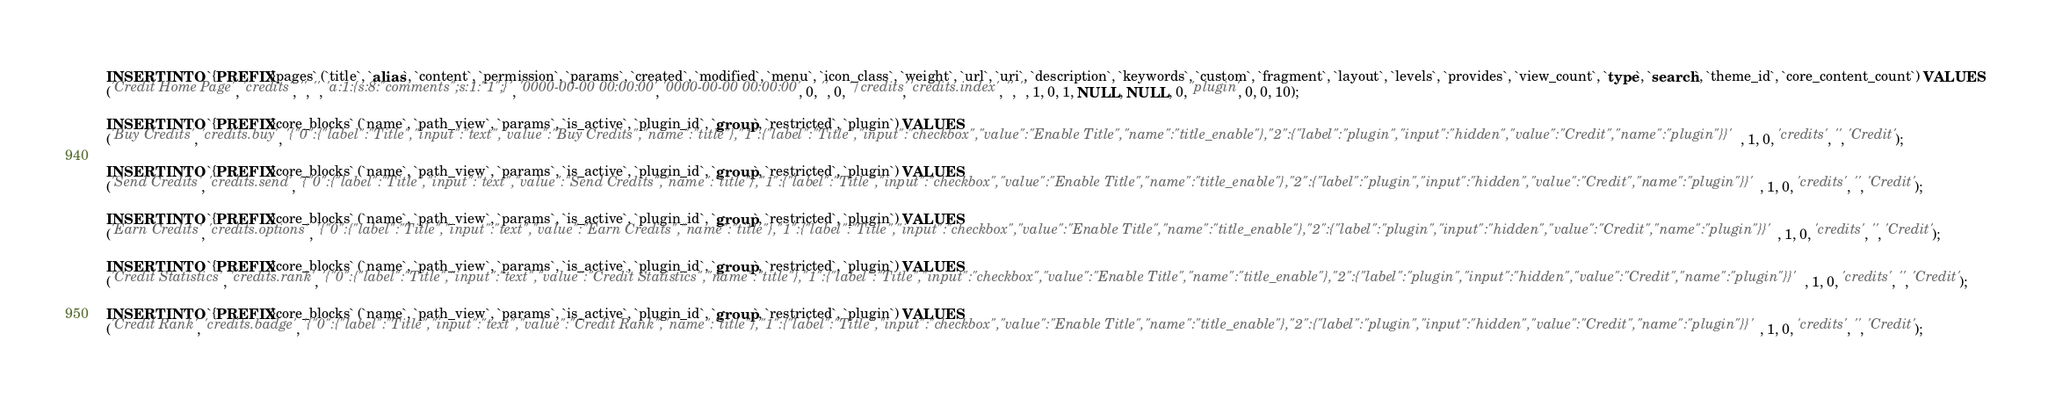Convert code to text. <code><loc_0><loc_0><loc_500><loc_500><_SQL_>
INSERT INTO `{PREFIX}pages` (`title`, `alias`, `content`, `permission`, `params`, `created`, `modified`, `menu`, `icon_class`, `weight`, `url`, `uri`, `description`, `keywords`, `custom`, `fragment`, `layout`, `levels`, `provides`, `view_count`, `type`, `search`, `theme_id`, `core_content_count`) VALUES
('Credit Home Page', 'credits', '', '', 'a:1:{s:8:"comments";s:1:"1";}', '0000-00-00 00:00:00', '0000-00-00 00:00:00', 0, '', 0, '/credits', 'credits.index', '', '', 1, 0, 1, NULL, NULL, 0, 'plugin', 0, 0, 10);

INSERT INTO `{PREFIX}core_blocks` (`name`, `path_view`, `params`, `is_active`, `plugin_id`, `group`, `restricted`, `plugin`) VALUES
('Buy Credits', 'credits.buy', '{"0":{"label":"Title","input":"text","value":"Buy Credits","name":"title"},"1":{"label":"Title","input":"checkbox","value":"Enable Title","name":"title_enable"},"2":{"label":"plugin","input":"hidden","value":"Credit","name":"plugin"}}', 1, 0, 'credits', '', 'Credit');

INSERT INTO `{PREFIX}core_blocks` (`name`, `path_view`, `params`, `is_active`, `plugin_id`, `group`, `restricted`, `plugin`) VALUES
('Send Credits', 'credits.send', '{"0":{"label":"Title","input":"text","value":"Send Credits","name":"title"},"1":{"label":"Title","input":"checkbox","value":"Enable Title","name":"title_enable"},"2":{"label":"plugin","input":"hidden","value":"Credit","name":"plugin"}}', 1, 0, 'credits', '', 'Credit');

INSERT INTO `{PREFIX}core_blocks` (`name`, `path_view`, `params`, `is_active`, `plugin_id`, `group`, `restricted`, `plugin`) VALUES
('Earn Credits', 'credits.options', '{"0":{"label":"Title","input":"text","value":"Earn Credits","name":"title"},"1":{"label":"Title","input":"checkbox","value":"Enable Title","name":"title_enable"},"2":{"label":"plugin","input":"hidden","value":"Credit","name":"plugin"}}', 1, 0, 'credits', '', 'Credit');

INSERT INTO `{PREFIX}core_blocks` (`name`, `path_view`, `params`, `is_active`, `plugin_id`, `group`, `restricted`, `plugin`) VALUES
('Credit Statistics', 'credits.rank', '{"0":{"label":"Title","input":"text","value":"Credit Statistics","name":"title"},"1":{"label":"Title","input":"checkbox","value":"Enable Title","name":"title_enable"},"2":{"label":"plugin","input":"hidden","value":"Credit","name":"plugin"}}', 1, 0, 'credits', '', 'Credit');

INSERT INTO `{PREFIX}core_blocks` (`name`, `path_view`, `params`, `is_active`, `plugin_id`, `group`, `restricted`, `plugin`) VALUES
('Credit Rank', 'credits.badge', '{"0":{"label":"Title","input":"text","value":"Credit Rank","name":"title"},"1":{"label":"Title","input":"checkbox","value":"Enable Title","name":"title_enable"},"2":{"label":"plugin","input":"hidden","value":"Credit","name":"plugin"}}', 1, 0, 'credits', '', 'Credit');
</code> 